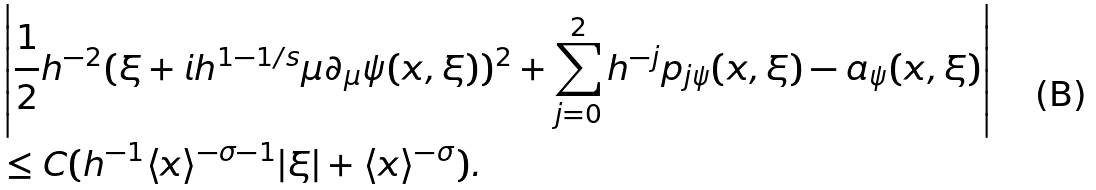Convert formula to latex. <formula><loc_0><loc_0><loc_500><loc_500>& \left | \frac { 1 } { 2 } h ^ { - 2 } ( \xi + i h ^ { 1 - 1 / s } \mu \partial _ { \mu } \psi ( x , \xi ) ) ^ { 2 } + \sum _ { j = 0 } ^ { 2 } h ^ { - j } p _ { j \psi } ( x , \xi ) - a _ { \psi } ( x , \xi ) \right | \\ & \leq C ( h ^ { - 1 } \langle x \rangle ^ { - \sigma - 1 } | \xi | + \langle x \rangle ^ { - \sigma } ) .</formula> 